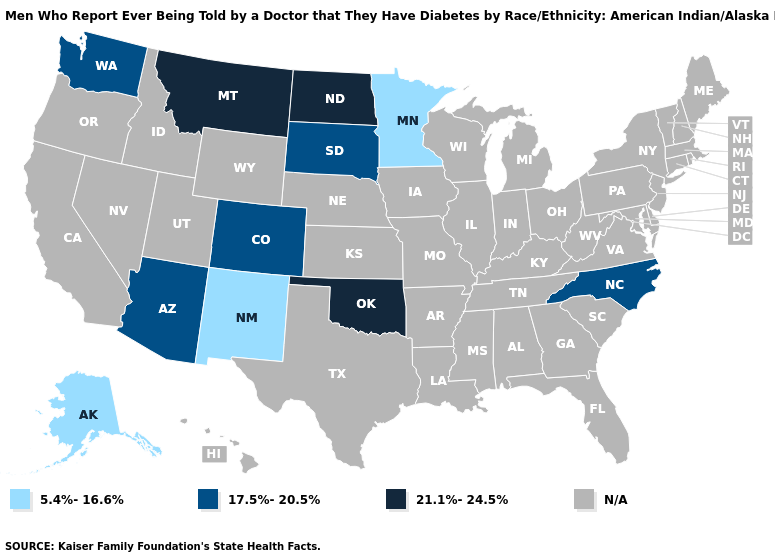Which states have the lowest value in the West?
Be succinct. Alaska, New Mexico. What is the lowest value in the South?
Short answer required. 17.5%-20.5%. Name the states that have a value in the range N/A?
Keep it brief. Alabama, Arkansas, California, Connecticut, Delaware, Florida, Georgia, Hawaii, Idaho, Illinois, Indiana, Iowa, Kansas, Kentucky, Louisiana, Maine, Maryland, Massachusetts, Michigan, Mississippi, Missouri, Nebraska, Nevada, New Hampshire, New Jersey, New York, Ohio, Oregon, Pennsylvania, Rhode Island, South Carolina, Tennessee, Texas, Utah, Vermont, Virginia, West Virginia, Wisconsin, Wyoming. Among the states that border Idaho , does Montana have the highest value?
Concise answer only. Yes. Does North Carolina have the lowest value in the USA?
Give a very brief answer. No. Name the states that have a value in the range 17.5%-20.5%?
Give a very brief answer. Arizona, Colorado, North Carolina, South Dakota, Washington. Name the states that have a value in the range N/A?
Answer briefly. Alabama, Arkansas, California, Connecticut, Delaware, Florida, Georgia, Hawaii, Idaho, Illinois, Indiana, Iowa, Kansas, Kentucky, Louisiana, Maine, Maryland, Massachusetts, Michigan, Mississippi, Missouri, Nebraska, Nevada, New Hampshire, New Jersey, New York, Ohio, Oregon, Pennsylvania, Rhode Island, South Carolina, Tennessee, Texas, Utah, Vermont, Virginia, West Virginia, Wisconsin, Wyoming. What is the value of Massachusetts?
Write a very short answer. N/A. What is the value of Michigan?
Quick response, please. N/A. Is the legend a continuous bar?
Quick response, please. No. Name the states that have a value in the range 21.1%-24.5%?
Give a very brief answer. Montana, North Dakota, Oklahoma. 